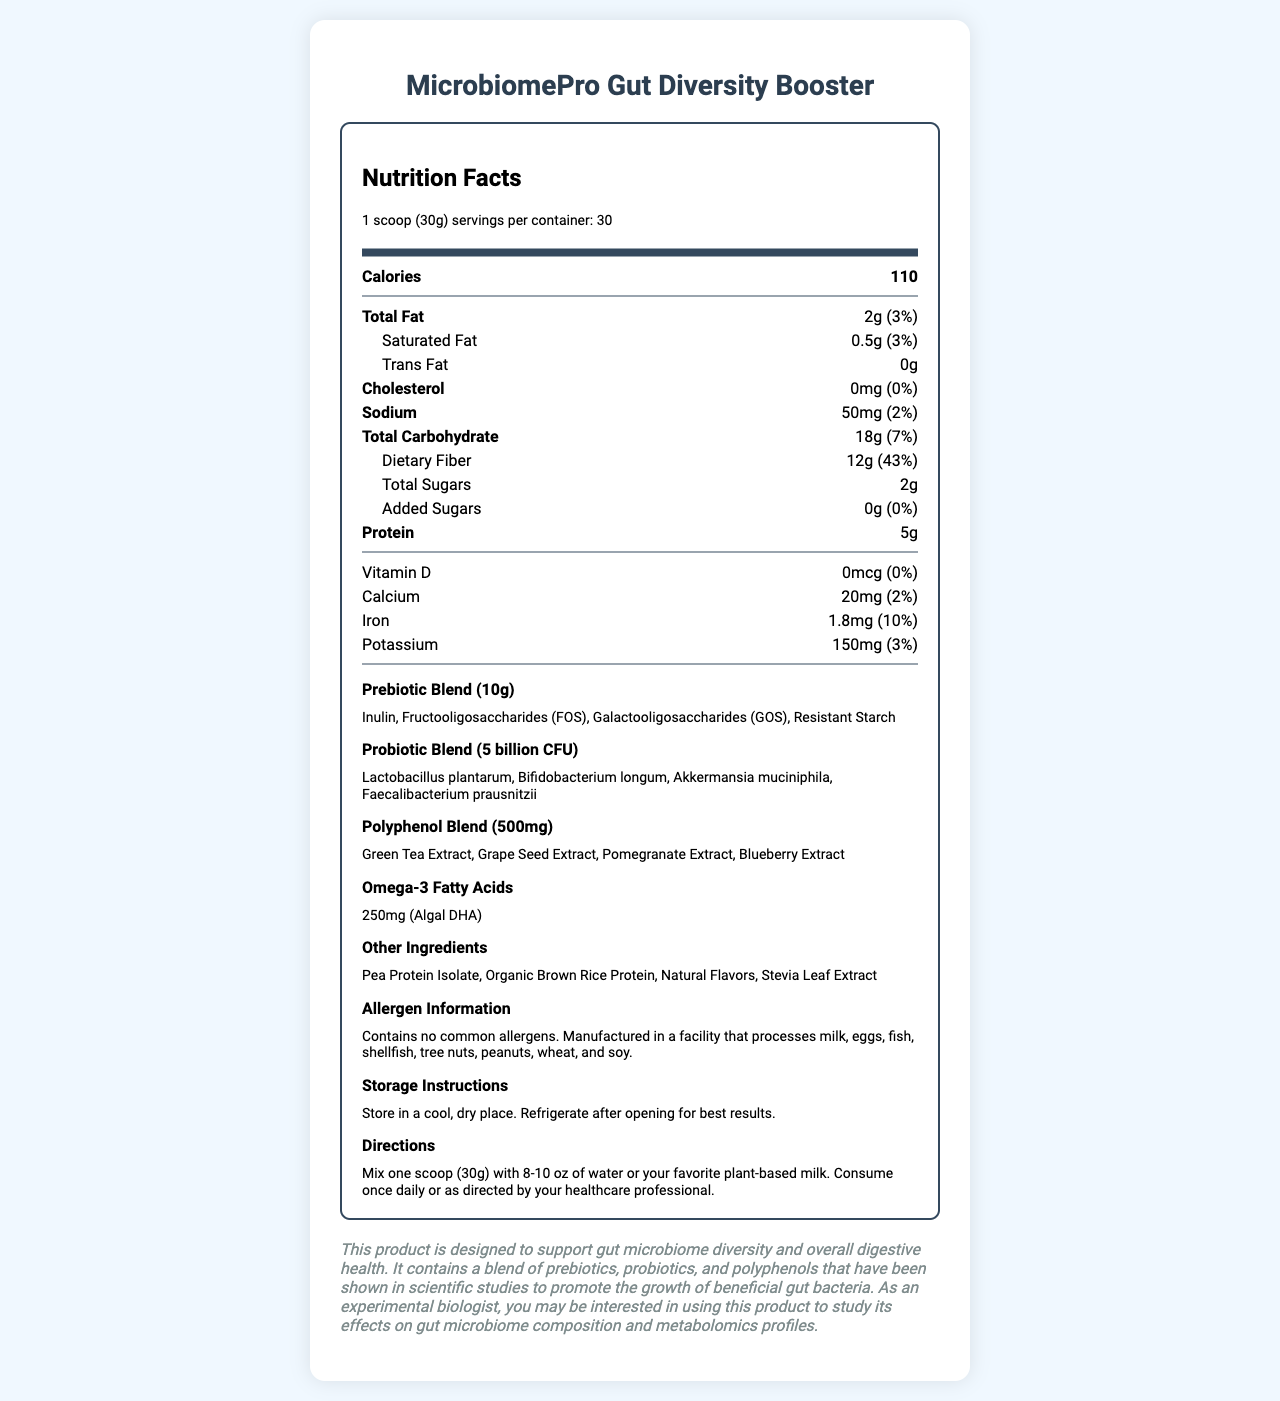what is the serving size? The serving size is explicitly stated as "1 scoop (30g)" in the document.
Answer: 1 scoop (30g) how many calories are in one serving? The document states that each serving contains 110 calories.
Answer: 110 calories what are the main components of the prebiotic blend? The prebiotic blend section lists these four ingredients.
Answer: Inulin, Fructooligosaccharides (FOS), Galactooligosaccharides (GOS), Resistant Starch what is the daily value percentage of dietary fiber in one serving? The document states that the dietary fiber in one serving represents 43% of the daily value.
Answer: 43% how much protein does one serving contain? The document states that each serving contains 5g of protein.
Answer: 5g how much total fat is in one serving? The document states that there are 2g of total fat in each serving.
Answer: 2g which probiotic strain is included in the blend? A. Lactobacillus acidophilus B. Bifidobacterium lactis C. Lactobacillus plantarum D. Bacillus coagulans The document lists Lactobacillus plantarum as one of the strains in the probiotic blend.
Answer: C how much sodium is in one serving? A. 20mg B. 50mg C. 100mg D. 150mg The document states that one serving contains 50mg of sodium.
Answer: B are there any added sugars in the product? The document explicitly states that there are 0g of added sugars.
Answer: No does the product contain any common allergens? The document specifies that the product contains no common allergens.
Answer: No what is the intended benefit of this product? The additional info section states this intended benefit.
Answer: To support gut microbiome diversity and overall digestive health describe the main idea of the document The document serves to inform consumers about the nutritional content, ingredient specifics, and the benefits of the product for enhancing gut microbiome diversity.
Answer: The document provides detailed nutrition and ingredient information for "MicrobiomePro Gut Diversity Booster." It highlights the contents and benefits of its prebiotic, probiotic, and polyphenol blends, along with other nutritional data such as calories, fats, sugars, and protein. how many calories come from total fat in one serving? The document does not provide enough information to calculate how many calories come specifically from total fat.
Answer: Cannot be determined 